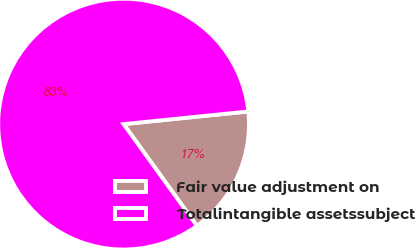<chart> <loc_0><loc_0><loc_500><loc_500><pie_chart><fcel>Fair value adjustment on<fcel>Totalintangible assetssubject<nl><fcel>16.67%<fcel>83.33%<nl></chart> 